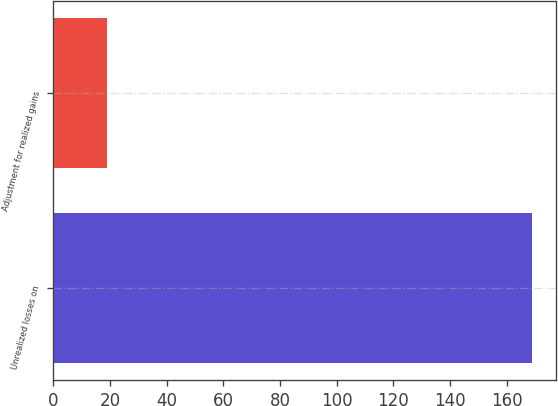<chart> <loc_0><loc_0><loc_500><loc_500><bar_chart><fcel>Unrealized losses on<fcel>Adjustment for realized gains<nl><fcel>168.9<fcel>19<nl></chart> 